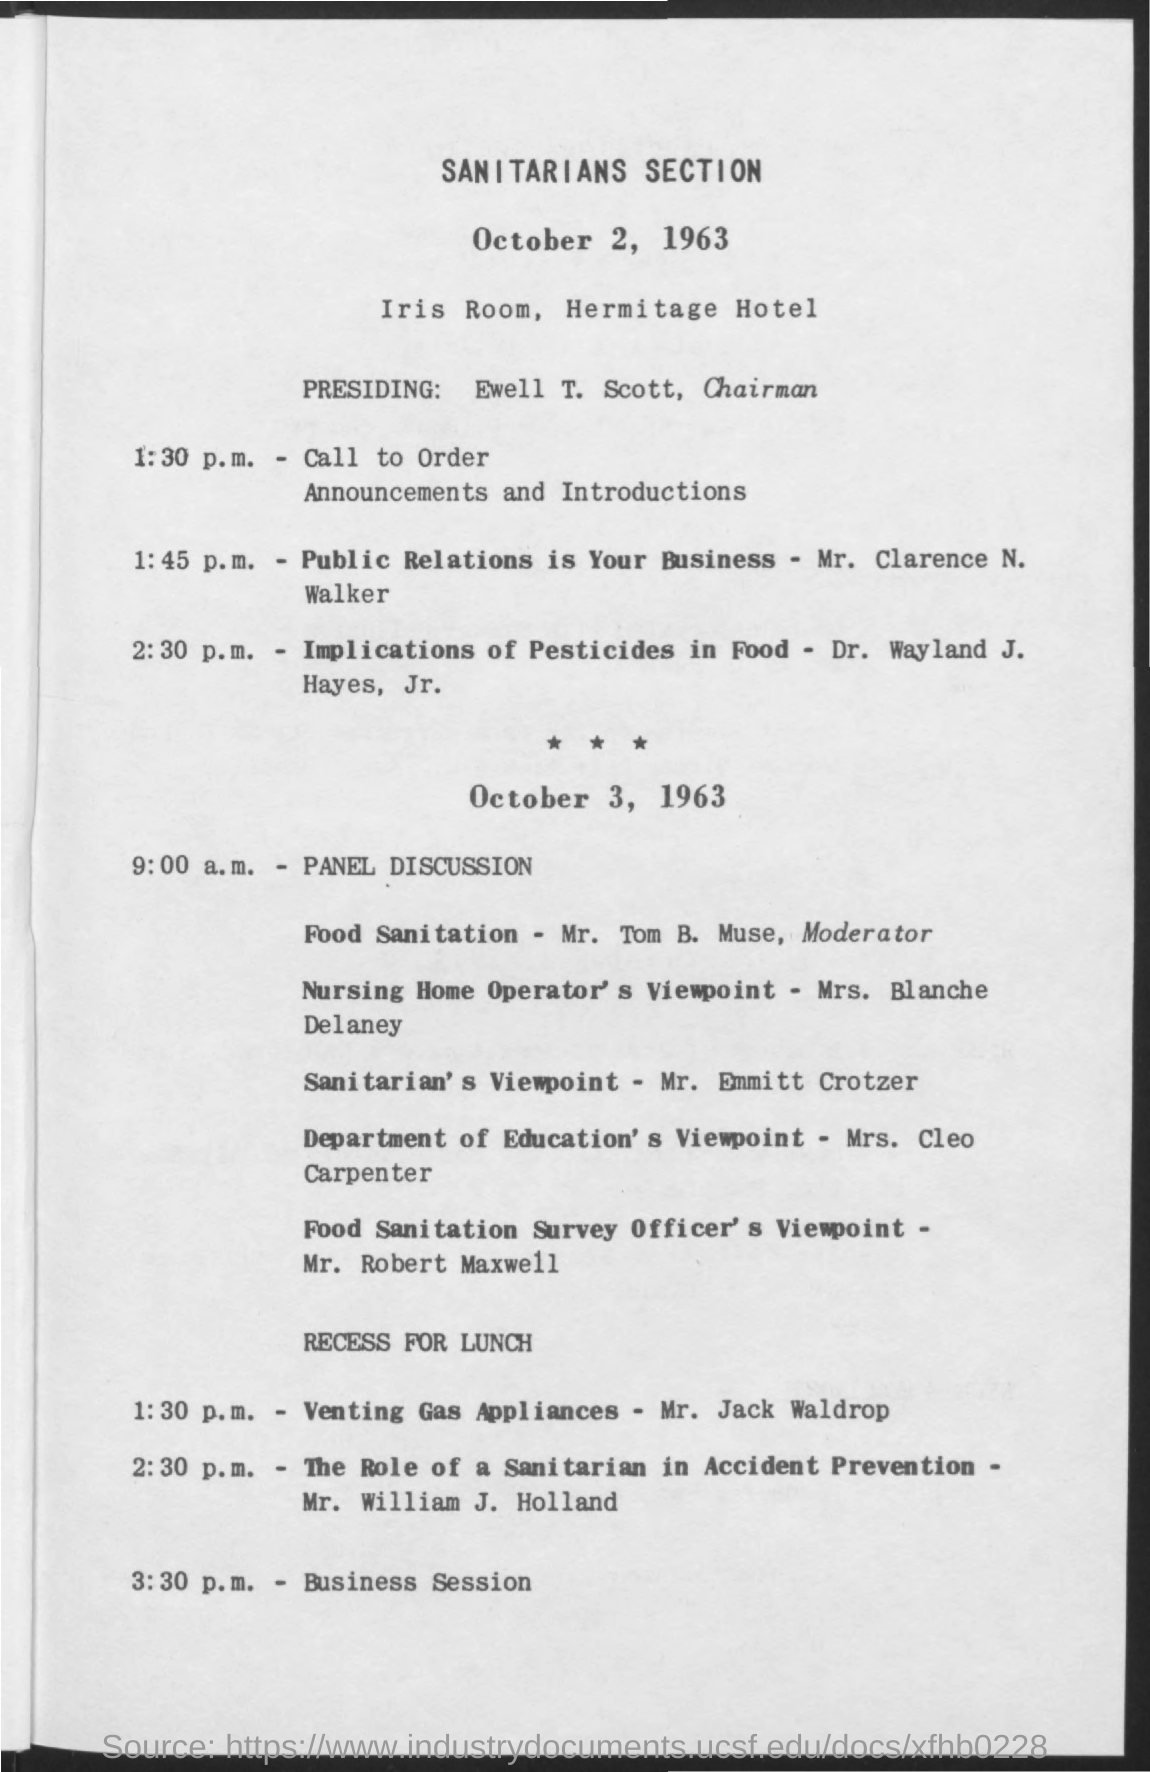what is the time mentioned for business session
 3:30 p.m. 